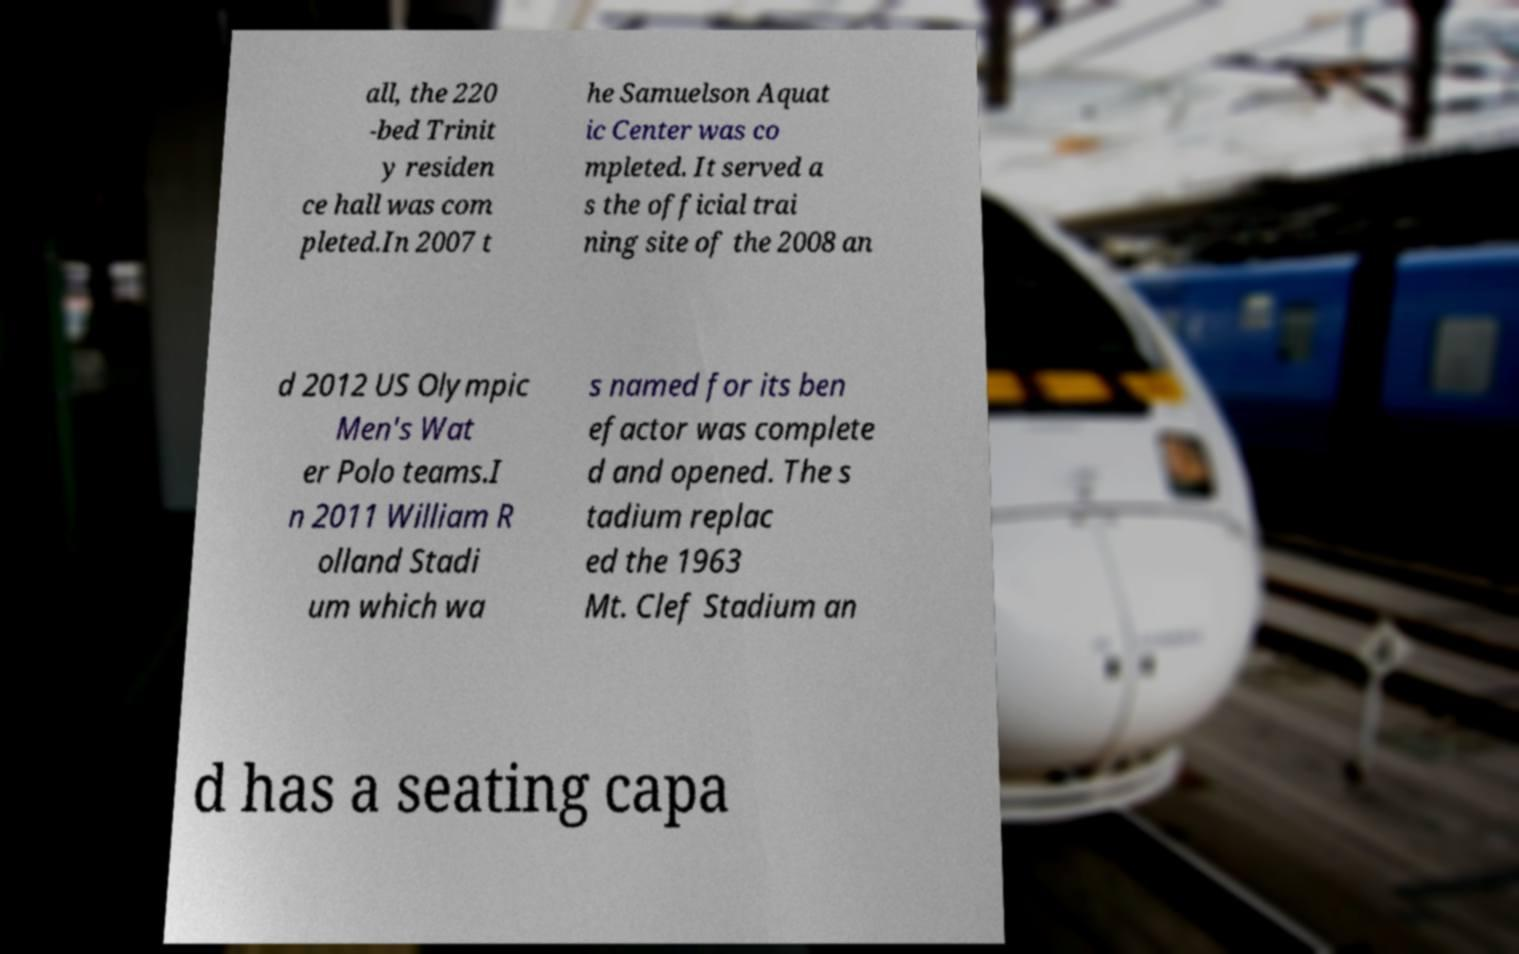Can you read and provide the text displayed in the image?This photo seems to have some interesting text. Can you extract and type it out for me? all, the 220 -bed Trinit y residen ce hall was com pleted.In 2007 t he Samuelson Aquat ic Center was co mpleted. It served a s the official trai ning site of the 2008 an d 2012 US Olympic Men's Wat er Polo teams.I n 2011 William R olland Stadi um which wa s named for its ben efactor was complete d and opened. The s tadium replac ed the 1963 Mt. Clef Stadium an d has a seating capa 